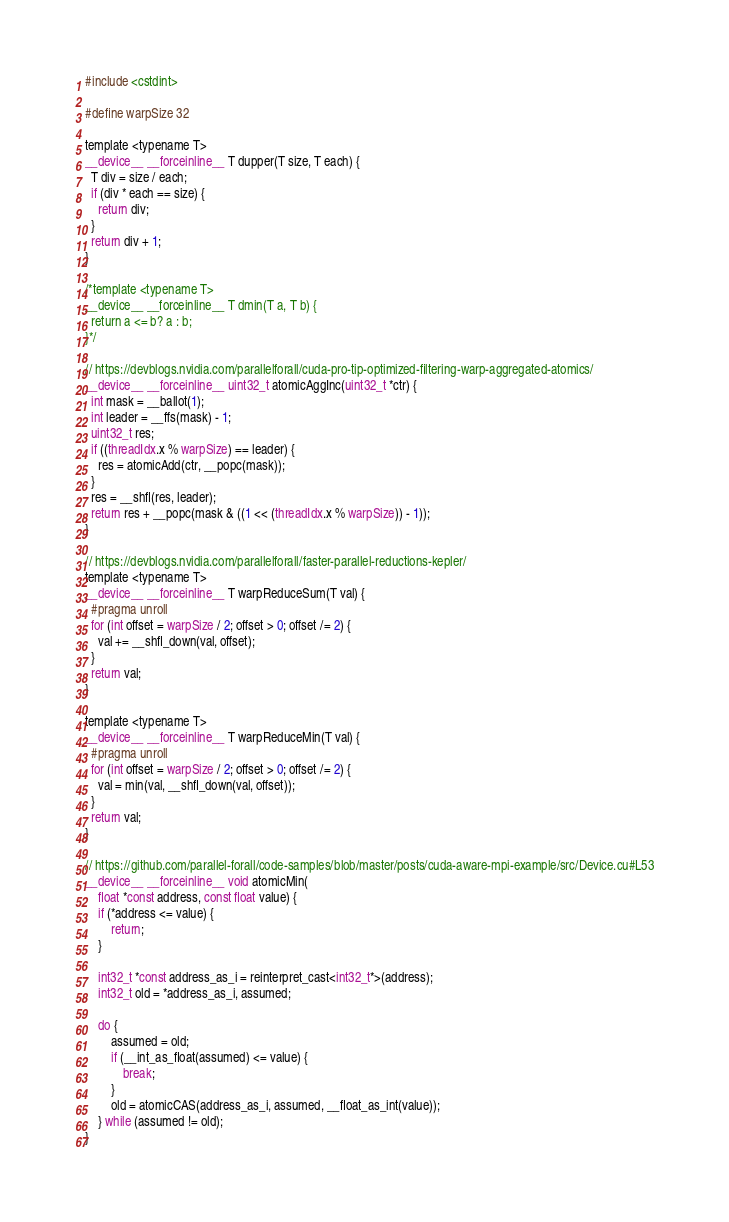<code> <loc_0><loc_0><loc_500><loc_500><_Cuda_>#include <cstdint>

#define warpSize 32

template <typename T>
__device__ __forceinline__ T dupper(T size, T each) {
  T div = size / each;
  if (div * each == size) {
    return div;
  }
  return div + 1;
}

/*template <typename T>
__device__ __forceinline__ T dmin(T a, T b) {
  return a <= b? a : b;
}*/

// https://devblogs.nvidia.com/parallelforall/cuda-pro-tip-optimized-filtering-warp-aggregated-atomics/
__device__ __forceinline__ uint32_t atomicAggInc(uint32_t *ctr) {
  int mask = __ballot(1);
  int leader = __ffs(mask) - 1;
  uint32_t res;
  if ((threadIdx.x % warpSize) == leader) {
    res = atomicAdd(ctr, __popc(mask));
  }
  res = __shfl(res, leader);
  return res + __popc(mask & ((1 << (threadIdx.x % warpSize)) - 1));
}

// https://devblogs.nvidia.com/parallelforall/faster-parallel-reductions-kepler/
template <typename T>
__device__ __forceinline__ T warpReduceSum(T val) {
  #pragma unroll
  for (int offset = warpSize / 2; offset > 0; offset /= 2) {
    val += __shfl_down(val, offset);
  }
  return val;
}

template <typename T>
__device__ __forceinline__ T warpReduceMin(T val) {
  #pragma unroll
  for (int offset = warpSize / 2; offset > 0; offset /= 2) {
    val = min(val, __shfl_down(val, offset));
  }
  return val;
}

// https://github.com/parallel-forall/code-samples/blob/master/posts/cuda-aware-mpi-example/src/Device.cu#L53
__device__ __forceinline__ void atomicMin(
    float *const address, const float value) {
	if (*address <= value) {
		return;
	}

	int32_t *const address_as_i = reinterpret_cast<int32_t*>(address);
	int32_t old = *address_as_i, assumed;

	do {
		assumed = old;
		if (__int_as_float(assumed) <= value) {
			break;
		}
		old = atomicCAS(address_as_i, assumed, __float_as_int(value));
	} while (assumed != old);
}
</code> 